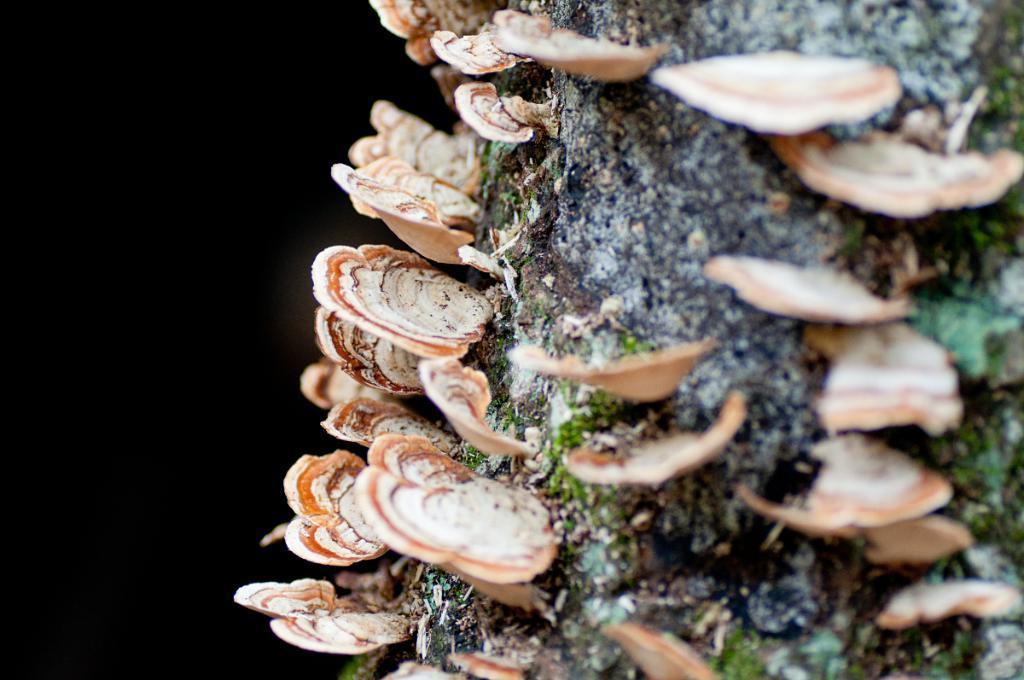In one or two sentences, can you explain what this image depicts? In this picture we can see polyporales on a wooden branch. On the left side of the picture it's dark. 